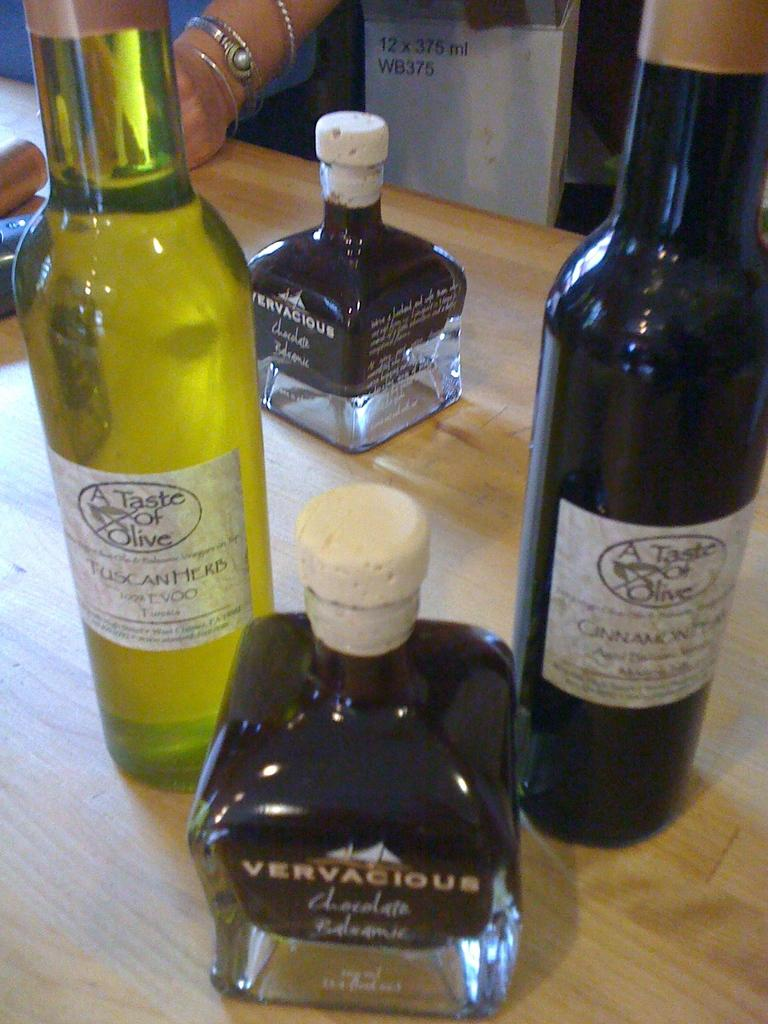Provide a one-sentence caption for the provided image. Various brands of olive oil including a tuscan herb variety. 